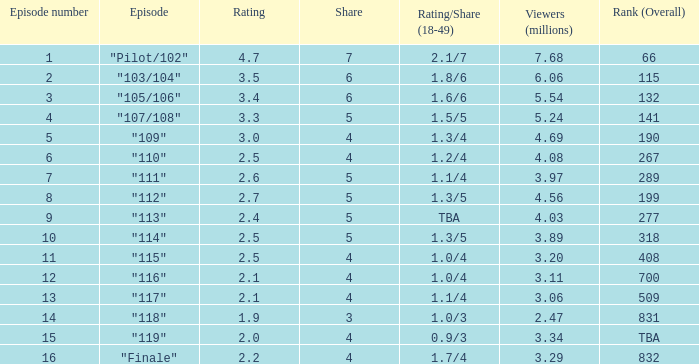47 million audience members? 0.0. Could you parse the entire table as a dict? {'header': ['Episode number', 'Episode', 'Rating', 'Share', 'Rating/Share (18-49)', 'Viewers (millions)', 'Rank (Overall)'], 'rows': [['1', '"Pilot/102"', '4.7', '7', '2.1/7', '7.68', '66'], ['2', '"103/104"', '3.5', '6', '1.8/6', '6.06', '115'], ['3', '"105/106"', '3.4', '6', '1.6/6', '5.54', '132'], ['4', '"107/108"', '3.3', '5', '1.5/5', '5.24', '141'], ['5', '"109"', '3.0', '4', '1.3/4', '4.69', '190'], ['6', '"110"', '2.5', '4', '1.2/4', '4.08', '267'], ['7', '"111"', '2.6', '5', '1.1/4', '3.97', '289'], ['8', '"112"', '2.7', '5', '1.3/5', '4.56', '199'], ['9', '"113"', '2.4', '5', 'TBA', '4.03', '277'], ['10', '"114"', '2.5', '5', '1.3/5', '3.89', '318'], ['11', '"115"', '2.5', '4', '1.0/4', '3.20', '408'], ['12', '"116"', '2.1', '4', '1.0/4', '3.11', '700'], ['13', '"117"', '2.1', '4', '1.1/4', '3.06', '509'], ['14', '"118"', '1.9', '3', '1.0/3', '2.47', '831'], ['15', '"119"', '2.0', '4', '0.9/3', '3.34', 'TBA'], ['16', '"Finale"', '2.2', '4', '1.7/4', '3.29', '832']]} 